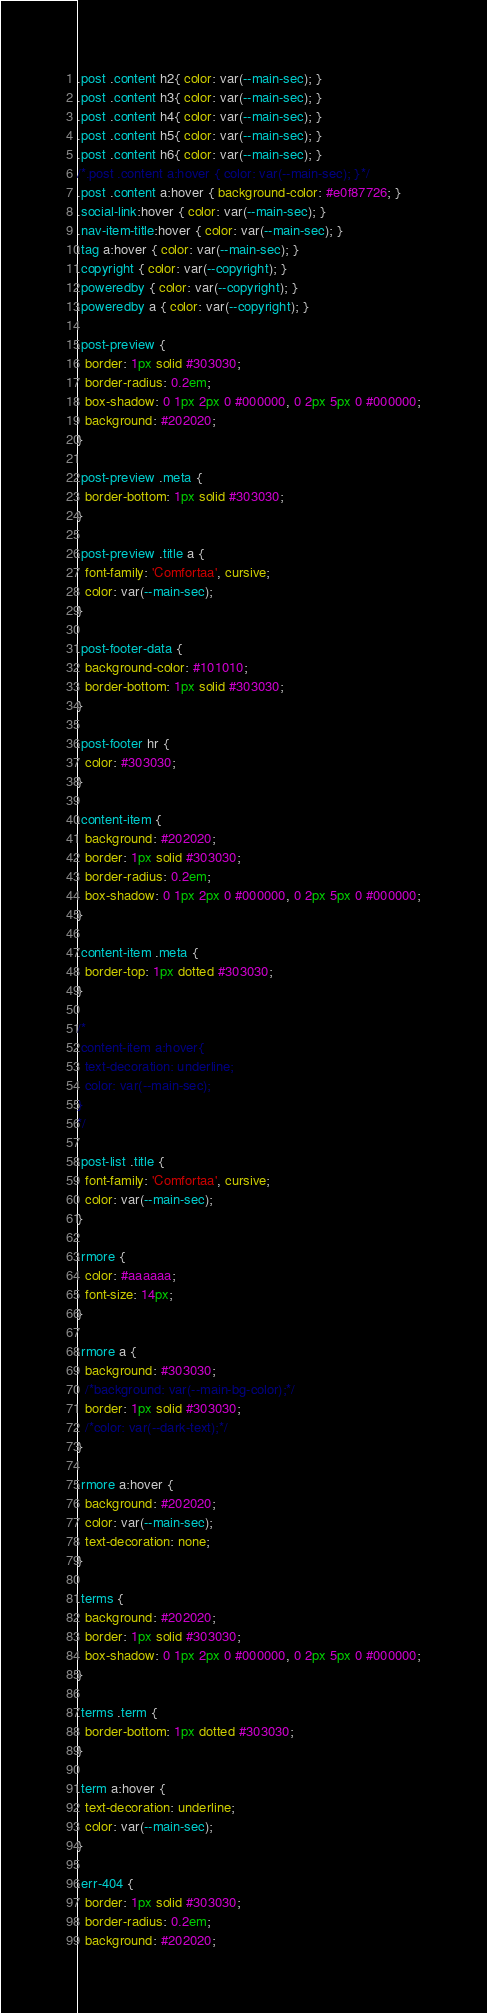<code> <loc_0><loc_0><loc_500><loc_500><_CSS_>.post .content h2{ color: var(--main-sec); }
.post .content h3{ color: var(--main-sec); }
.post .content h4{ color: var(--main-sec); }
.post .content h5{ color: var(--main-sec); }
.post .content h6{ color: var(--main-sec); }
/*.post .content a:hover { color: var(--main-sec); }*/
.post .content a:hover { background-color: #e0f87726; }
.social-link:hover { color: var(--main-sec); }
.nav-item-title:hover { color: var(--main-sec); }
.tag a:hover { color: var(--main-sec); }
.copyright { color: var(--copyright); }
.poweredby { color: var(--copyright); }
.poweredby a { color: var(--copyright); }

.post-preview {
  border: 1px solid #303030;
  border-radius: 0.2em;
  box-shadow: 0 1px 2px 0 #000000, 0 2px 5px 0 #000000;
  background: #202020;
}

.post-preview .meta {
  border-bottom: 1px solid #303030;
}

.post-preview .title a {
  font-family: 'Comfortaa', cursive;    
  color: var(--main-sec);
}

.post-footer-data {
  background-color: #101010;
  border-bottom: 1px solid #303030;
}

.post-footer hr {
  color: #303030;
}

.content-item {
  background: #202020;
  border: 1px solid #303030;
  border-radius: 0.2em;
  box-shadow: 0 1px 2px 0 #000000, 0 2px 5px 0 #000000;
}

.content-item .meta {
  border-top: 1px dotted #303030;
}

/*
.content-item a:hover{
  text-decoration: underline;
  color: var(--main-sec);
}
*/

.post-list .title {
  font-family: 'Comfortaa', cursive;  
  color: var(--main-sec);
}

.rmore {
  color: #aaaaaa;
  font-size: 14px;
}

.rmore a {
  background: #303030;
  /*background: var(--main-bg-color);*/
  border: 1px solid #303030;
  /*color: var(--dark-text);*/
}

.rmore a:hover {
  background: #202020;
  color: var(--main-sec);
  text-decoration: none;
}

.terms {
  background: #202020;
  border: 1px solid #303030;
  box-shadow: 0 1px 2px 0 #000000, 0 2px 5px 0 #000000;
}

.terms .term {
  border-bottom: 1px dotted #303030;
}

.term a:hover {
  text-decoration: underline;
  color: var(--main-sec);
}

.err-404 {
  border: 1px solid #303030;
  border-radius: 0.2em;
  background: #202020;</code> 